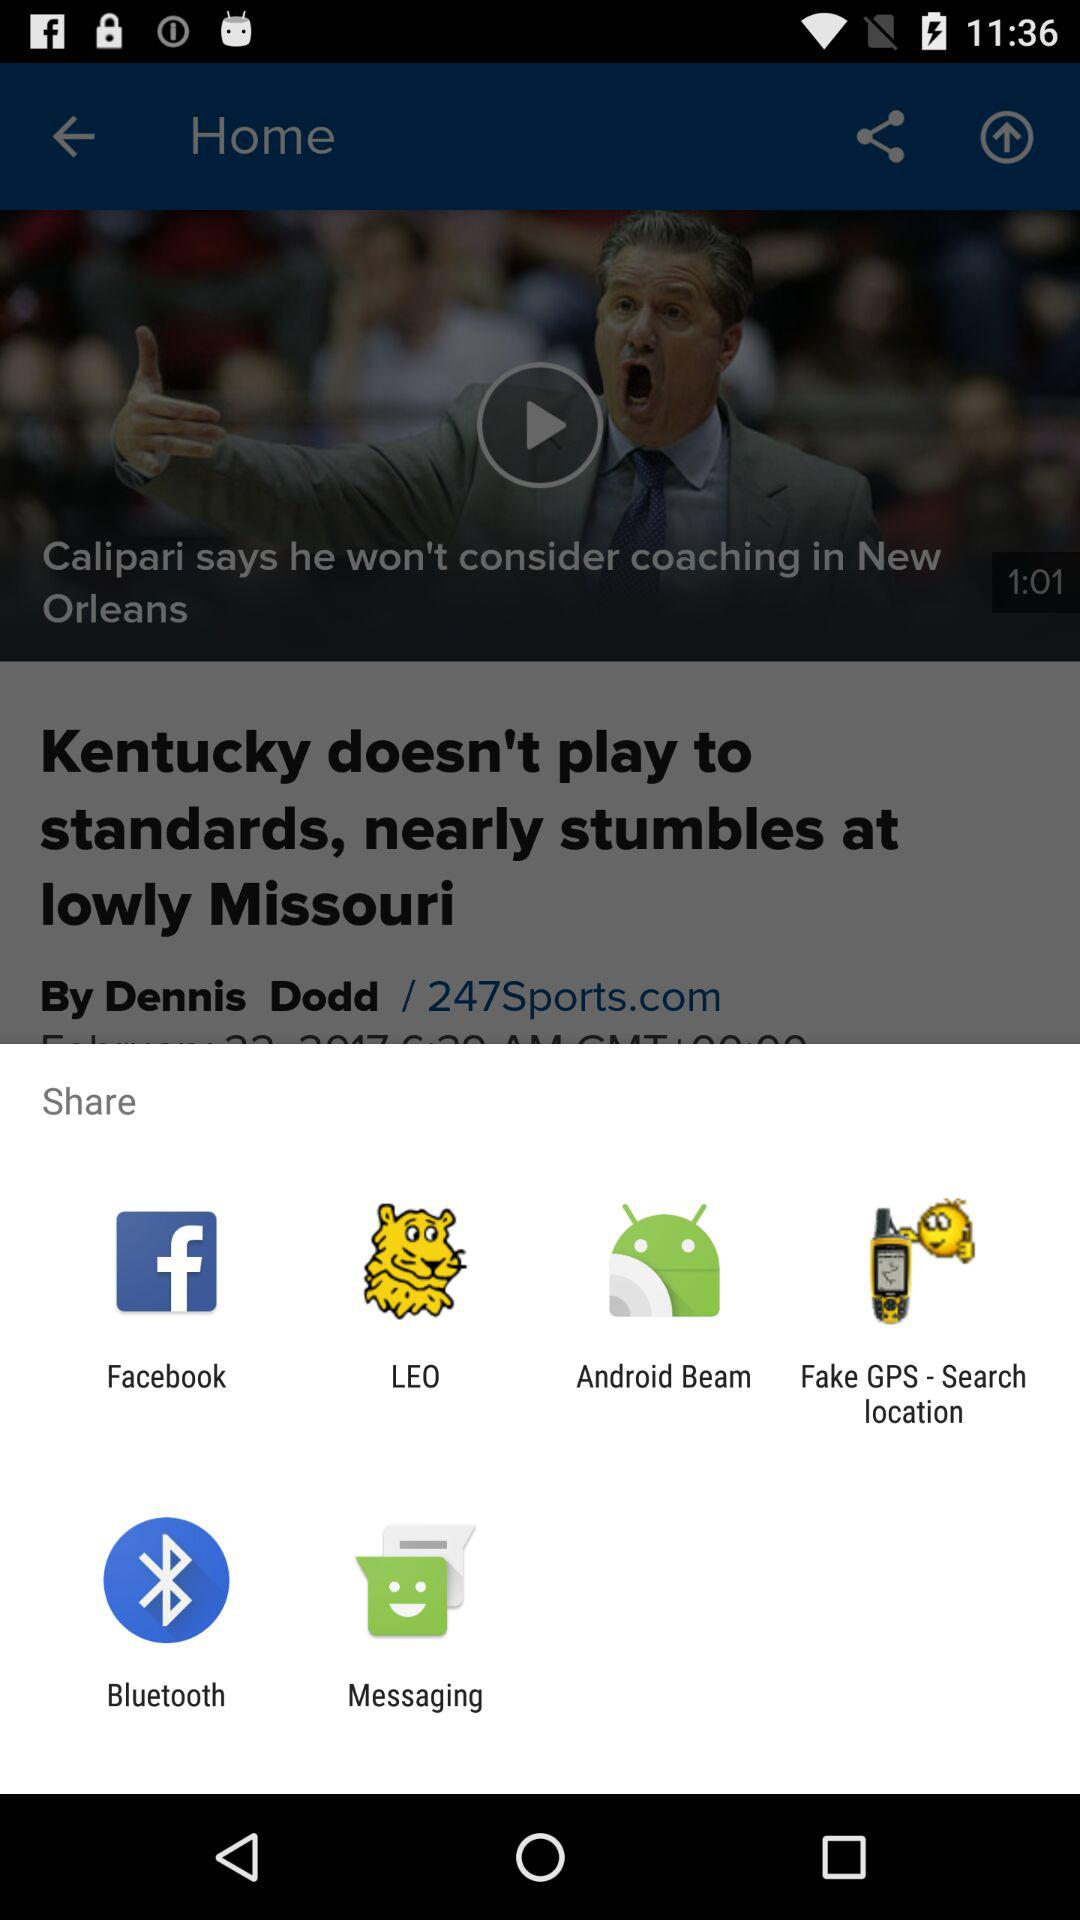Through which applications can we share? You can share through "Facebook", "LEO", "Android Beam", "Fake GPS - Search location", "Bluetooth" and "Messaging". 